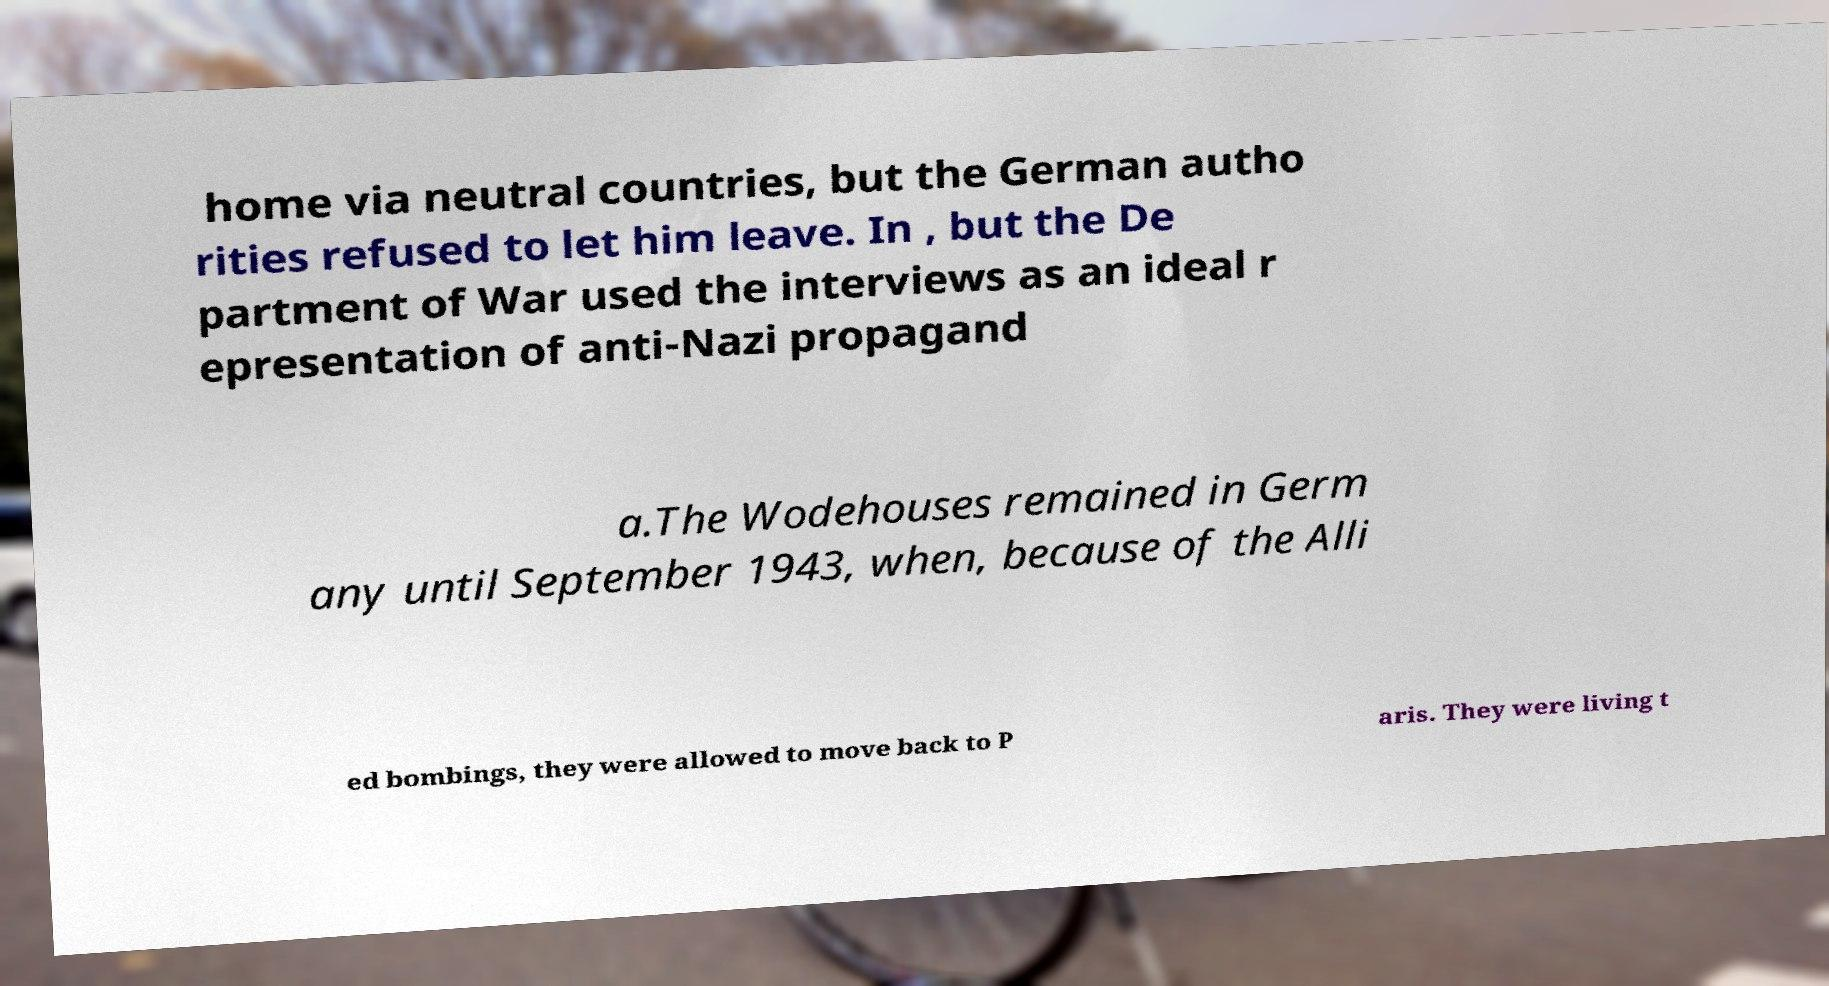Please identify and transcribe the text found in this image. home via neutral countries, but the German autho rities refused to let him leave. In , but the De partment of War used the interviews as an ideal r epresentation of anti-Nazi propagand a.The Wodehouses remained in Germ any until September 1943, when, because of the Alli ed bombings, they were allowed to move back to P aris. They were living t 